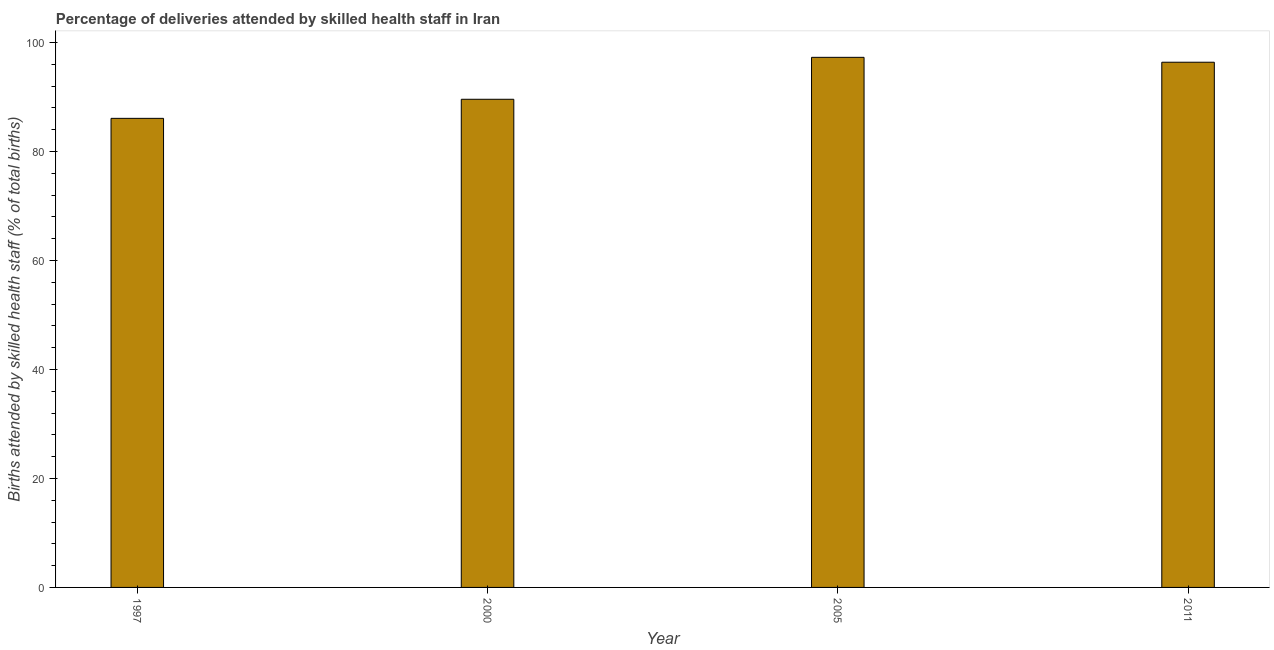Does the graph contain any zero values?
Your answer should be compact. No. What is the title of the graph?
Ensure brevity in your answer.  Percentage of deliveries attended by skilled health staff in Iran. What is the label or title of the Y-axis?
Offer a terse response. Births attended by skilled health staff (% of total births). What is the number of births attended by skilled health staff in 1997?
Make the answer very short. 86.1. Across all years, what is the maximum number of births attended by skilled health staff?
Your response must be concise. 97.3. Across all years, what is the minimum number of births attended by skilled health staff?
Keep it short and to the point. 86.1. In which year was the number of births attended by skilled health staff maximum?
Make the answer very short. 2005. What is the sum of the number of births attended by skilled health staff?
Offer a terse response. 369.4. What is the average number of births attended by skilled health staff per year?
Your answer should be very brief. 92.35. What is the median number of births attended by skilled health staff?
Ensure brevity in your answer.  93. In how many years, is the number of births attended by skilled health staff greater than 96 %?
Give a very brief answer. 2. What is the ratio of the number of births attended by skilled health staff in 1997 to that in 2000?
Offer a terse response. 0.96. Is the number of births attended by skilled health staff in 2005 less than that in 2011?
Ensure brevity in your answer.  No. What is the difference between the highest and the second highest number of births attended by skilled health staff?
Your answer should be very brief. 0.9. Is the sum of the number of births attended by skilled health staff in 2000 and 2005 greater than the maximum number of births attended by skilled health staff across all years?
Keep it short and to the point. Yes. What is the difference between the highest and the lowest number of births attended by skilled health staff?
Offer a terse response. 11.2. How many bars are there?
Your answer should be very brief. 4. How many years are there in the graph?
Make the answer very short. 4. What is the difference between two consecutive major ticks on the Y-axis?
Provide a succinct answer. 20. What is the Births attended by skilled health staff (% of total births) in 1997?
Offer a very short reply. 86.1. What is the Births attended by skilled health staff (% of total births) of 2000?
Your answer should be compact. 89.6. What is the Births attended by skilled health staff (% of total births) in 2005?
Give a very brief answer. 97.3. What is the Births attended by skilled health staff (% of total births) in 2011?
Keep it short and to the point. 96.4. What is the difference between the Births attended by skilled health staff (% of total births) in 1997 and 2005?
Ensure brevity in your answer.  -11.2. What is the ratio of the Births attended by skilled health staff (% of total births) in 1997 to that in 2000?
Make the answer very short. 0.96. What is the ratio of the Births attended by skilled health staff (% of total births) in 1997 to that in 2005?
Ensure brevity in your answer.  0.89. What is the ratio of the Births attended by skilled health staff (% of total births) in 1997 to that in 2011?
Provide a short and direct response. 0.89. What is the ratio of the Births attended by skilled health staff (% of total births) in 2000 to that in 2005?
Your response must be concise. 0.92. What is the ratio of the Births attended by skilled health staff (% of total births) in 2000 to that in 2011?
Make the answer very short. 0.93. 